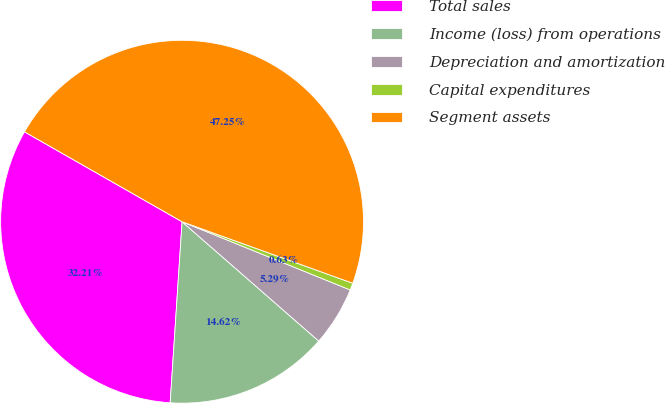Convert chart to OTSL. <chart><loc_0><loc_0><loc_500><loc_500><pie_chart><fcel>Total sales<fcel>Income (loss) from operations<fcel>Depreciation and amortization<fcel>Capital expenditures<fcel>Segment assets<nl><fcel>32.21%<fcel>14.62%<fcel>5.29%<fcel>0.63%<fcel>47.25%<nl></chart> 